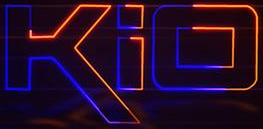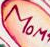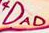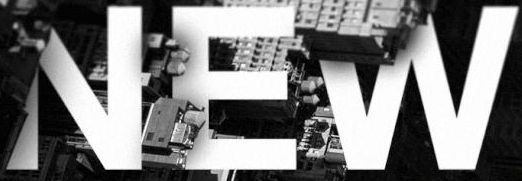Identify the words shown in these images in order, separated by a semicolon. kio; MOM; DAD; NEW 